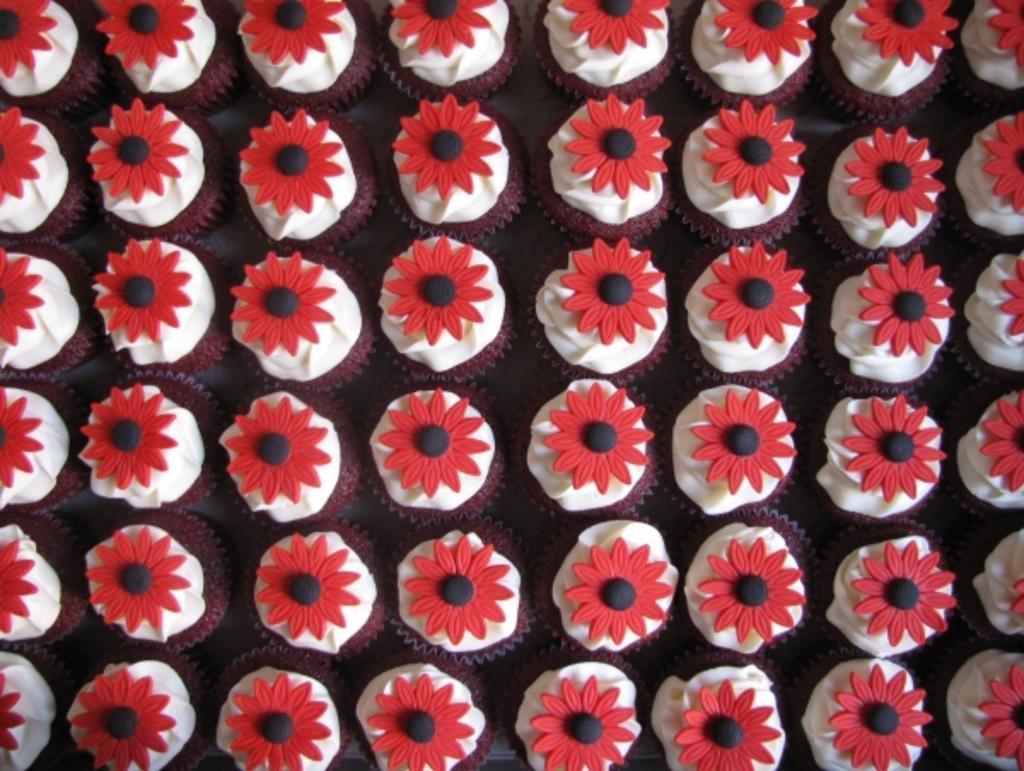Please provide a concise description of this image. In this image we can see cupcakes placed on the surface. 